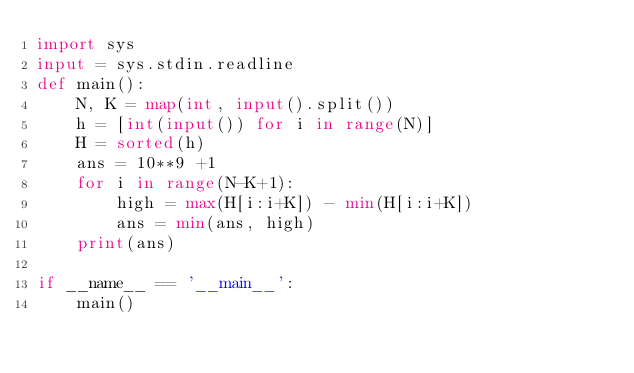Convert code to text. <code><loc_0><loc_0><loc_500><loc_500><_Python_>import sys
input = sys.stdin.readline
def main():
    N, K = map(int, input().split())
    h = [int(input()) for i in range(N)]
    H = sorted(h)
    ans = 10**9 +1
    for i in range(N-K+1):
        high = max(H[i:i+K]) - min(H[i:i+K])
        ans = min(ans, high)
    print(ans)

if __name__ == '__main__':
    main()</code> 